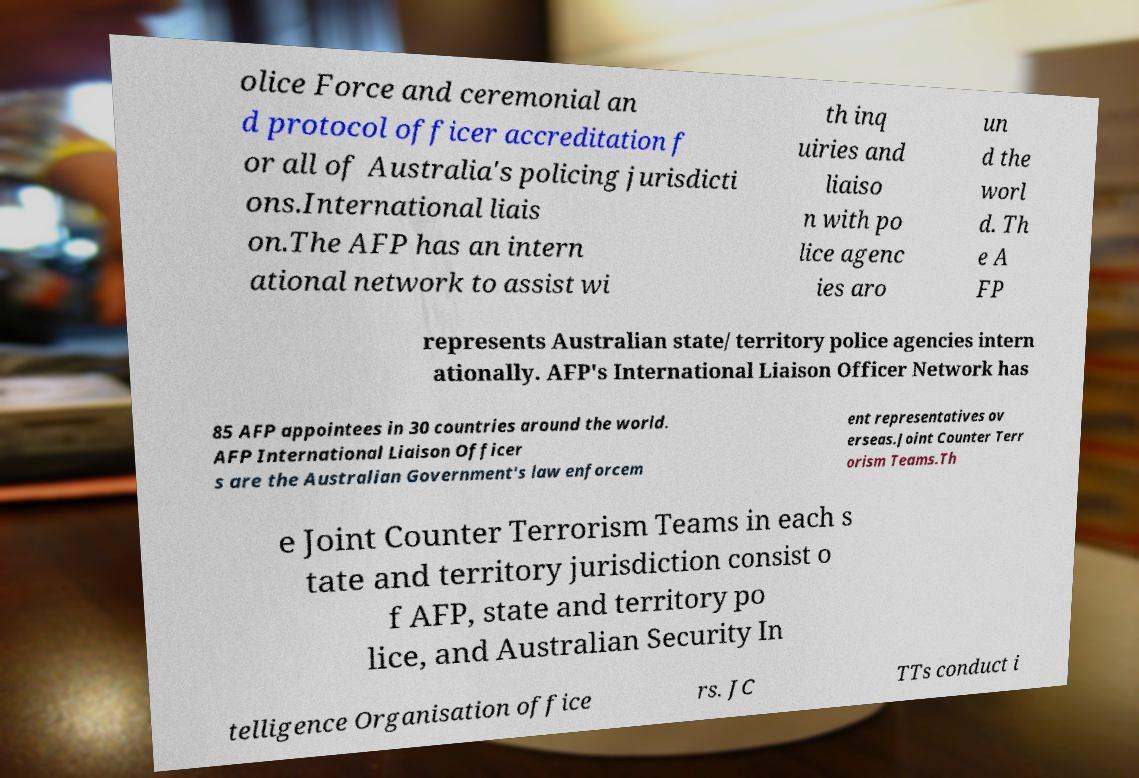Can you accurately transcribe the text from the provided image for me? olice Force and ceremonial an d protocol officer accreditation f or all of Australia's policing jurisdicti ons.International liais on.The AFP has an intern ational network to assist wi th inq uiries and liaiso n with po lice agenc ies aro un d the worl d. Th e A FP represents Australian state/ territory police agencies intern ationally. AFP's International Liaison Officer Network has 85 AFP appointees in 30 countries around the world. AFP International Liaison Officer s are the Australian Government's law enforcem ent representatives ov erseas.Joint Counter Terr orism Teams.Th e Joint Counter Terrorism Teams in each s tate and territory jurisdiction consist o f AFP, state and territory po lice, and Australian Security In telligence Organisation office rs. JC TTs conduct i 